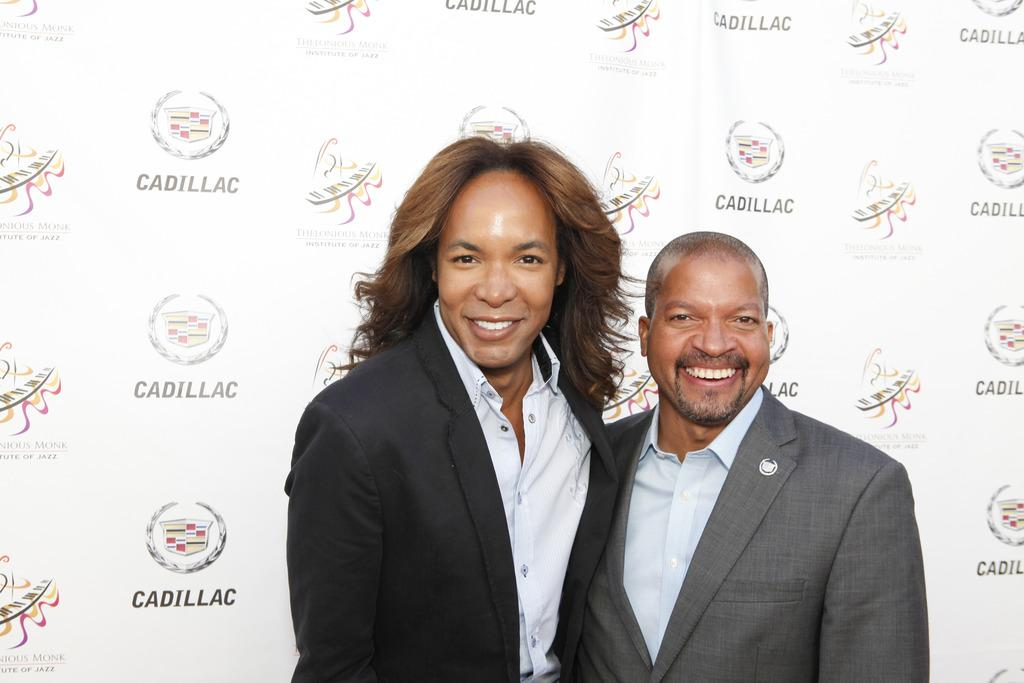How many people are in the image? There are two persons in the image. What are the persons doing in the image? The persons are standing and smiling. What can be seen in the background of the image? There is a hoarding in the background of the image. What is on the hoarding? The hoarding has words and logos on it. What type of chain can be seen connecting the two persons in the image? There is no chain connecting the two persons in the image; they are standing independently. What kind of toys are the persons holding in the image? There are no toys present in the image; the persons are not holding anything. 